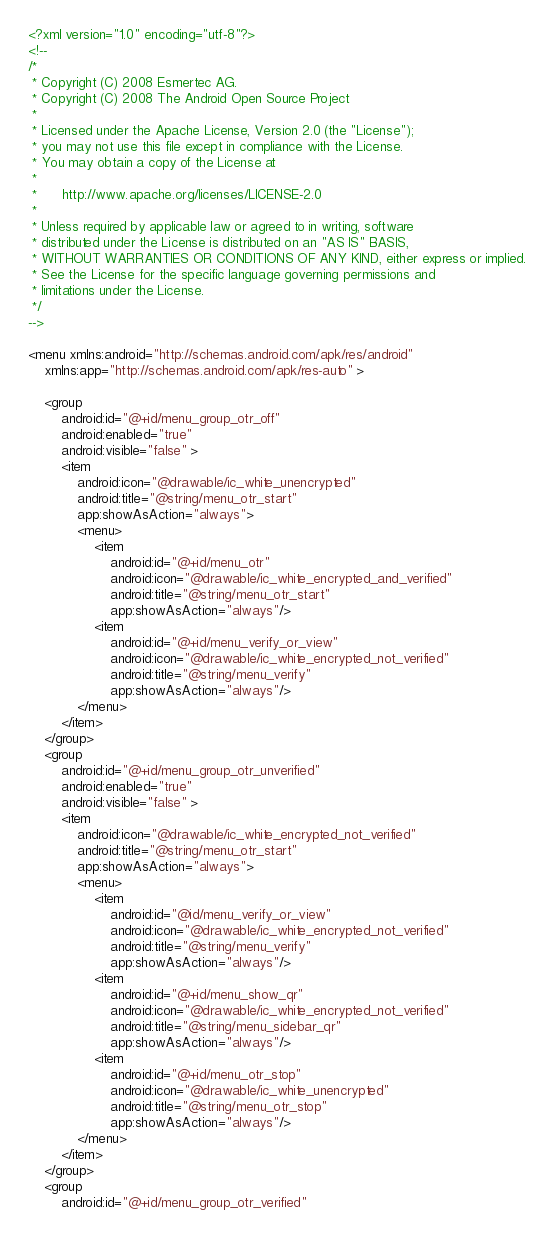Convert code to text. <code><loc_0><loc_0><loc_500><loc_500><_XML_><?xml version="1.0" encoding="utf-8"?>
<!--
/*
 * Copyright (C) 2008 Esmertec AG.
 * Copyright (C) 2008 The Android Open Source Project
 *
 * Licensed under the Apache License, Version 2.0 (the "License");
 * you may not use this file except in compliance with the License.
 * You may obtain a copy of the License at
 *
 *      http://www.apache.org/licenses/LICENSE-2.0
 *
 * Unless required by applicable law or agreed to in writing, software
 * distributed under the License is distributed on an "AS IS" BASIS,
 * WITHOUT WARRANTIES OR CONDITIONS OF ANY KIND, either express or implied.
 * See the License for the specific language governing permissions and
 * limitations under the License.
 */
-->

<menu xmlns:android="http://schemas.android.com/apk/res/android"
    xmlns:app="http://schemas.android.com/apk/res-auto" >

    <group
        android:id="@+id/menu_group_otr_off"
        android:enabled="true"
        android:visible="false" >
        <item
            android:icon="@drawable/ic_white_unencrypted"
            android:title="@string/menu_otr_start"
            app:showAsAction="always">
            <menu>
                <item
                    android:id="@+id/menu_otr"
                    android:icon="@drawable/ic_white_encrypted_and_verified"
                    android:title="@string/menu_otr_start"
                    app:showAsAction="always"/>
                <item
                    android:id="@+id/menu_verify_or_view"
                    android:icon="@drawable/ic_white_encrypted_not_verified"
                    android:title="@string/menu_verify"
                    app:showAsAction="always"/>
            </menu>
        </item>
    </group>
    <group
        android:id="@+id/menu_group_otr_unverified"
        android:enabled="true"
        android:visible="false" >
        <item
            android:icon="@drawable/ic_white_encrypted_not_verified"
            android:title="@string/menu_otr_start"
            app:showAsAction="always">
            <menu>
                <item
                    android:id="@id/menu_verify_or_view"
                    android:icon="@drawable/ic_white_encrypted_not_verified"
                    android:title="@string/menu_verify"
                    app:showAsAction="always"/>
                <item
                    android:id="@+id/menu_show_qr"
                    android:icon="@drawable/ic_white_encrypted_not_verified"
                    android:title="@string/menu_sidebar_qr"
                    app:showAsAction="always"/>
                <item
                    android:id="@+id/menu_otr_stop"
                    android:icon="@drawable/ic_white_unencrypted"
                    android:title="@string/menu_otr_stop"
                    app:showAsAction="always"/>
            </menu>
        </item>
    </group>
    <group
        android:id="@+id/menu_group_otr_verified"</code> 